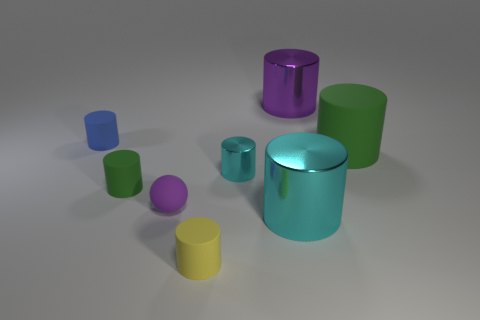Subtract 1 cylinders. How many cylinders are left? 6 Subtract all yellow cylinders. How many cylinders are left? 6 Subtract all small cyan metal cylinders. How many cylinders are left? 6 Add 2 big purple rubber blocks. How many objects exist? 10 Subtract all yellow cylinders. Subtract all purple blocks. How many cylinders are left? 6 Subtract all spheres. How many objects are left? 7 Add 5 large gray cylinders. How many large gray cylinders exist? 5 Subtract 1 cyan cylinders. How many objects are left? 7 Subtract all purple metallic spheres. Subtract all tiny cyan things. How many objects are left? 7 Add 4 big cyan cylinders. How many big cyan cylinders are left? 5 